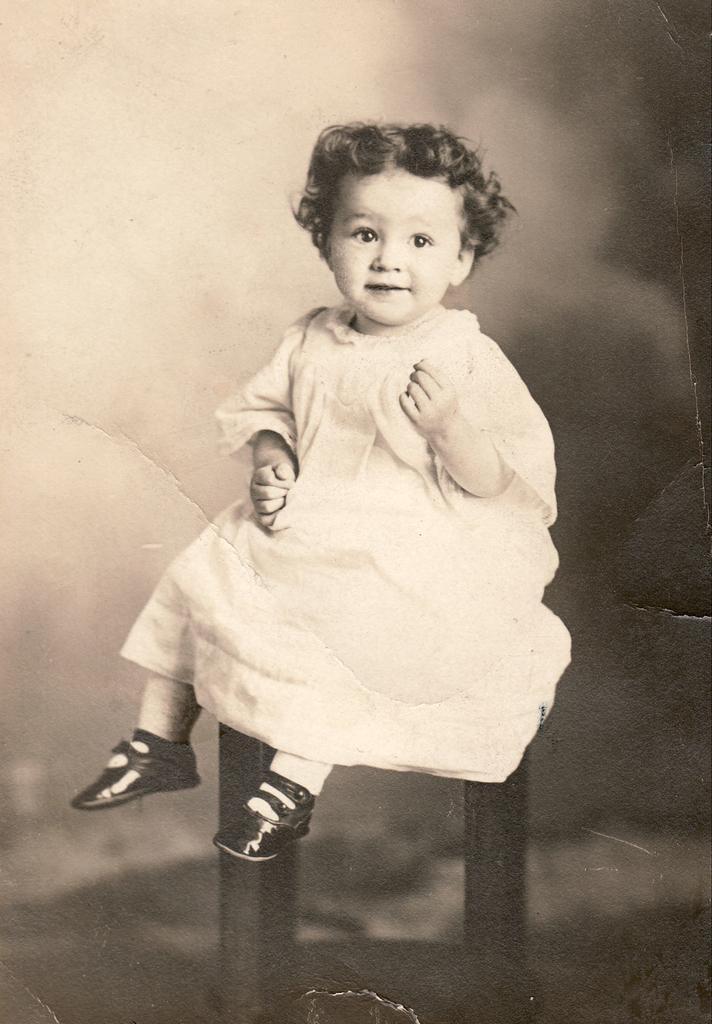Could you give a brief overview of what you see in this image? It is a black and white image there is a baby sitting on a stool. 